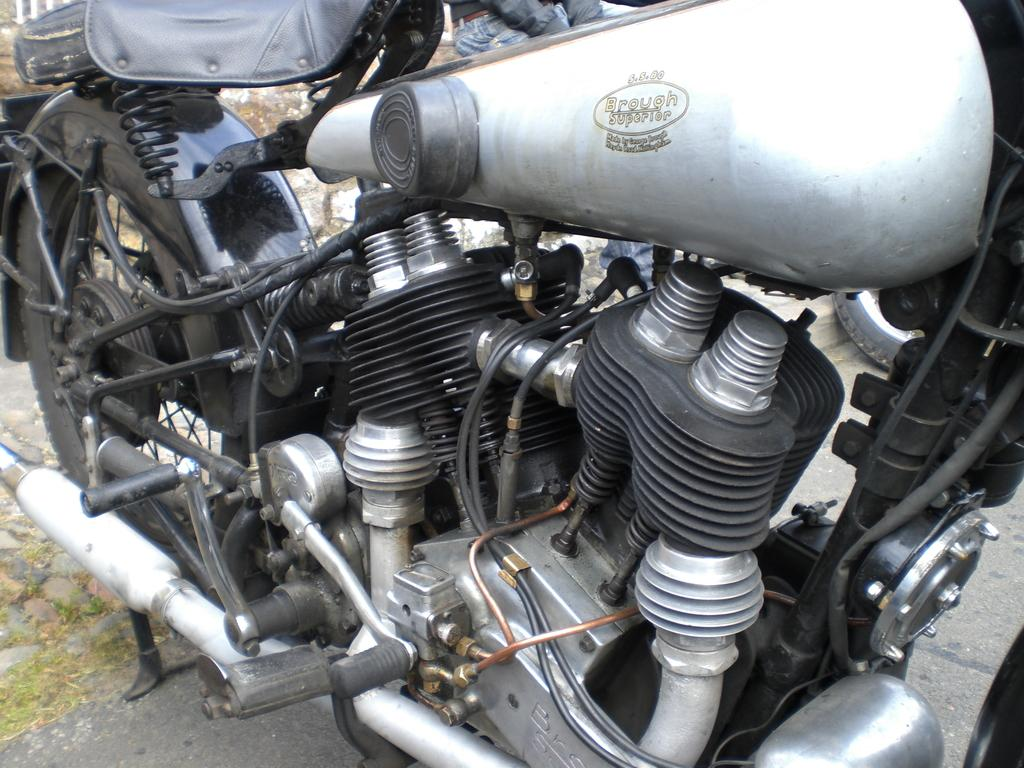What is the main subject of the image? The main subject of the image is a motorbike. Can you describe anything else visible in the image? There is a person in the background of the image and a road visible at the bottom of the image. What is the stomach size of the person in the image? There is no information about the person's stomach size in the image. 